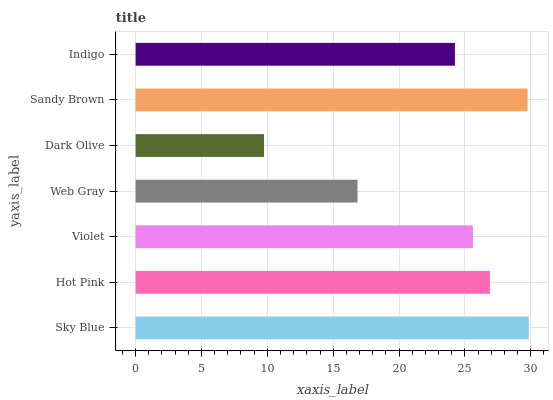Is Dark Olive the minimum?
Answer yes or no. Yes. Is Sky Blue the maximum?
Answer yes or no. Yes. Is Hot Pink the minimum?
Answer yes or no. No. Is Hot Pink the maximum?
Answer yes or no. No. Is Sky Blue greater than Hot Pink?
Answer yes or no. Yes. Is Hot Pink less than Sky Blue?
Answer yes or no. Yes. Is Hot Pink greater than Sky Blue?
Answer yes or no. No. Is Sky Blue less than Hot Pink?
Answer yes or no. No. Is Violet the high median?
Answer yes or no. Yes. Is Violet the low median?
Answer yes or no. Yes. Is Indigo the high median?
Answer yes or no. No. Is Hot Pink the low median?
Answer yes or no. No. 